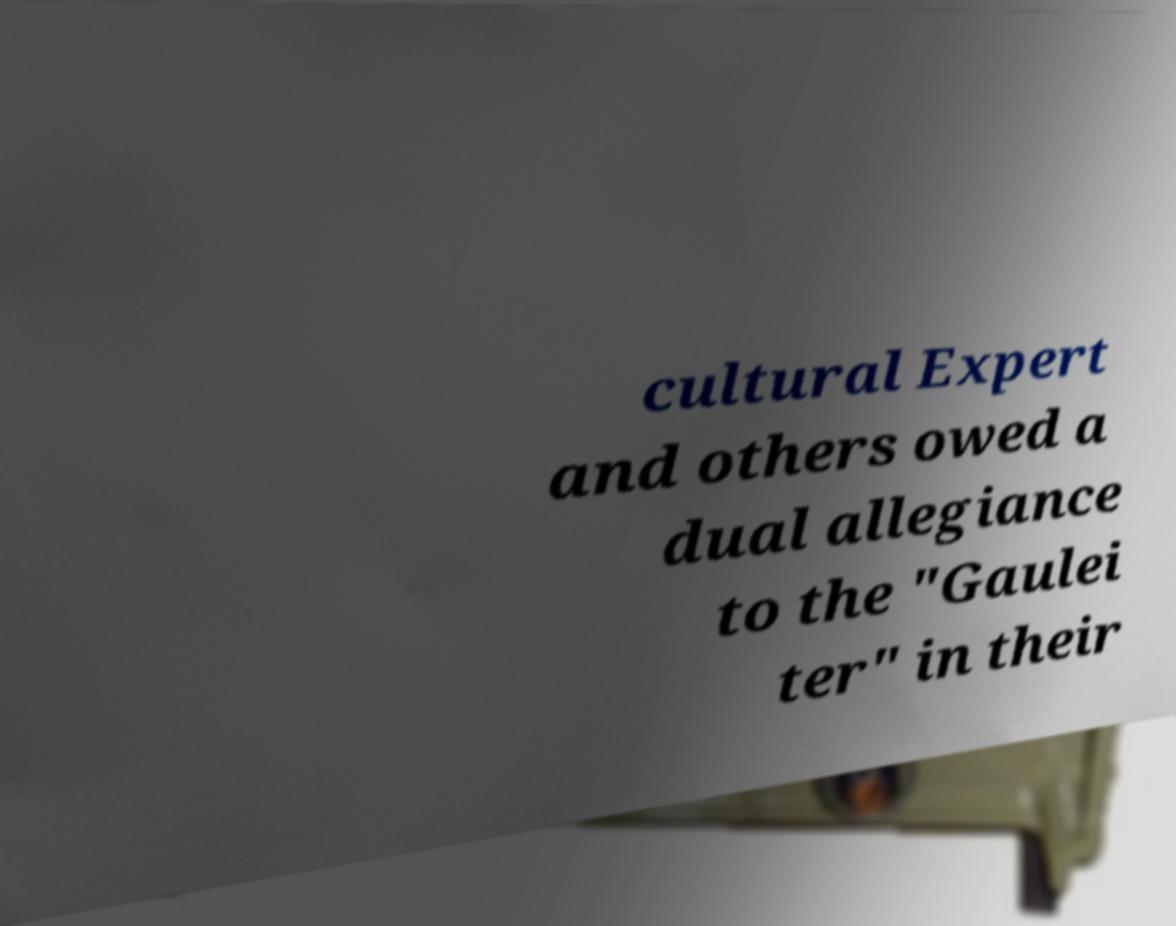Can you read and provide the text displayed in the image?This photo seems to have some interesting text. Can you extract and type it out for me? cultural Expert and others owed a dual allegiance to the "Gaulei ter" in their 